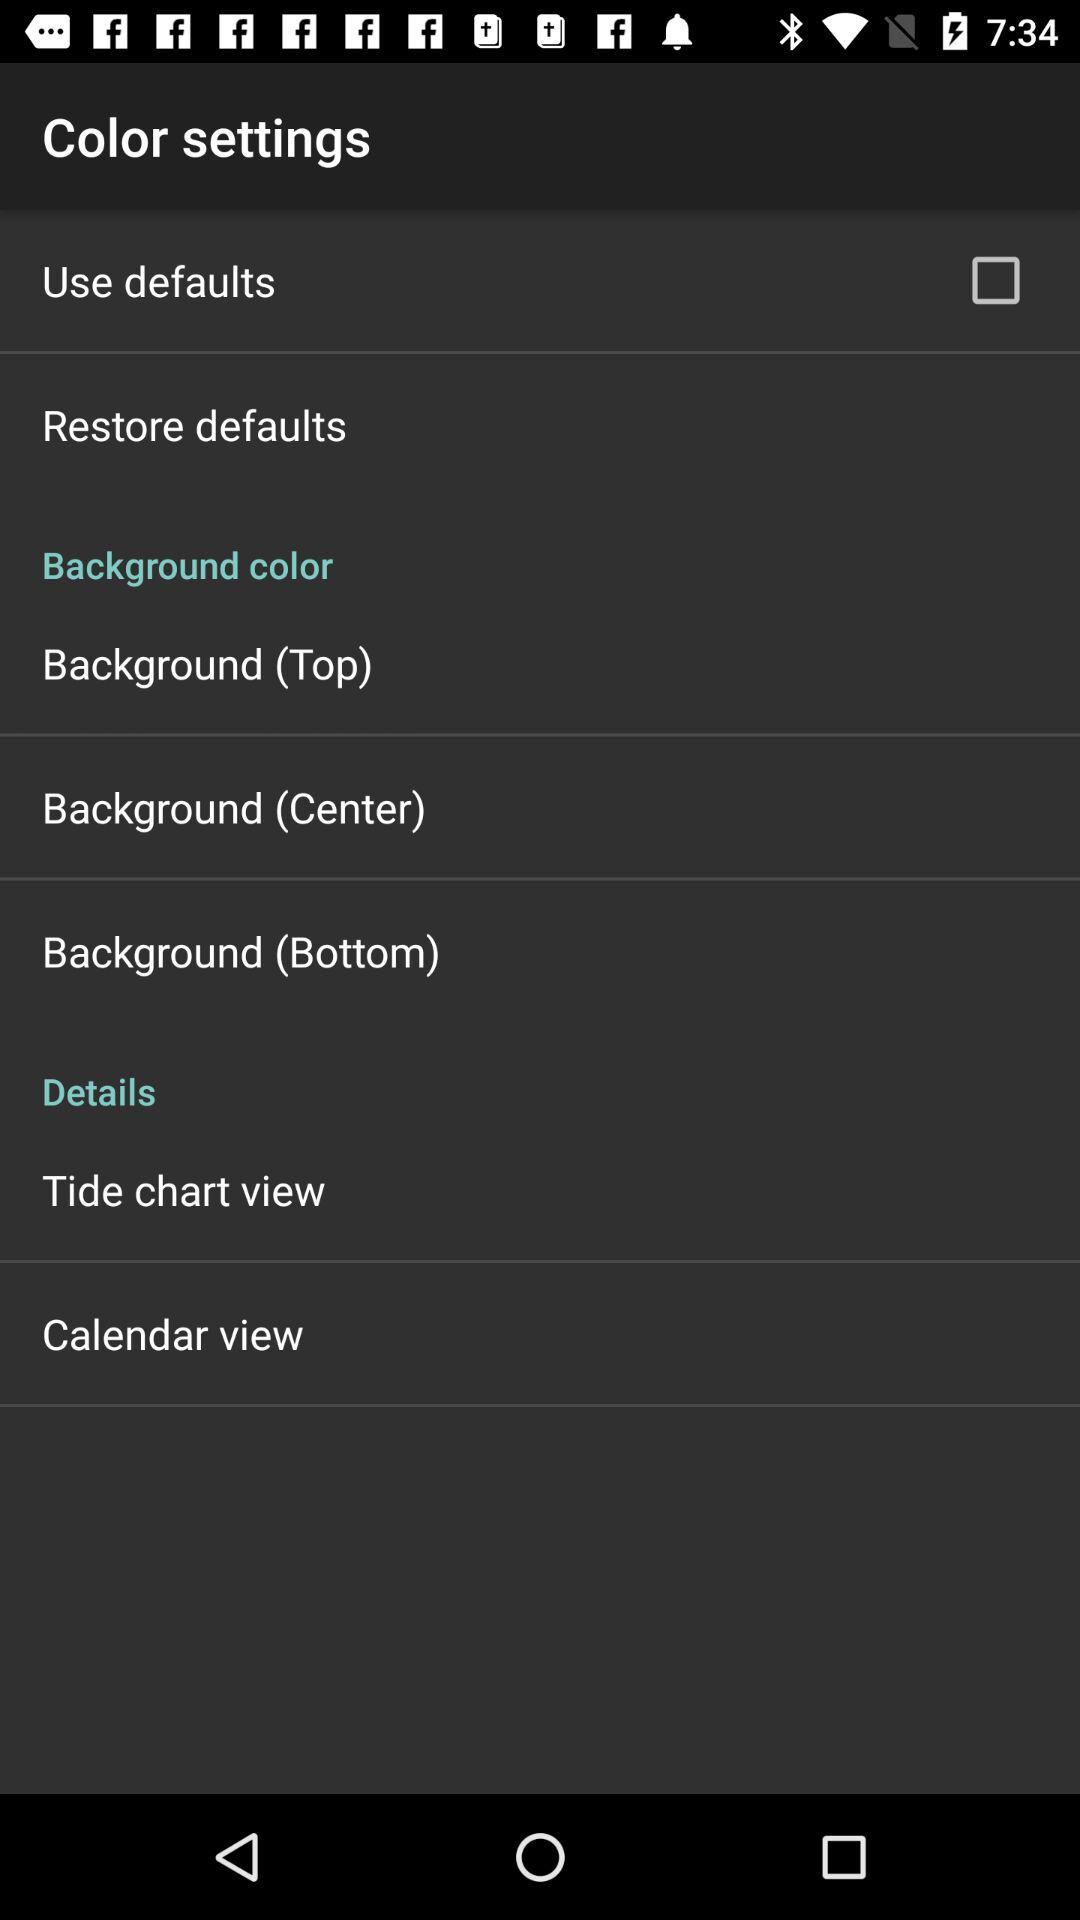How many rows are there in the details section?
Answer the question using a single word or phrase. 2 